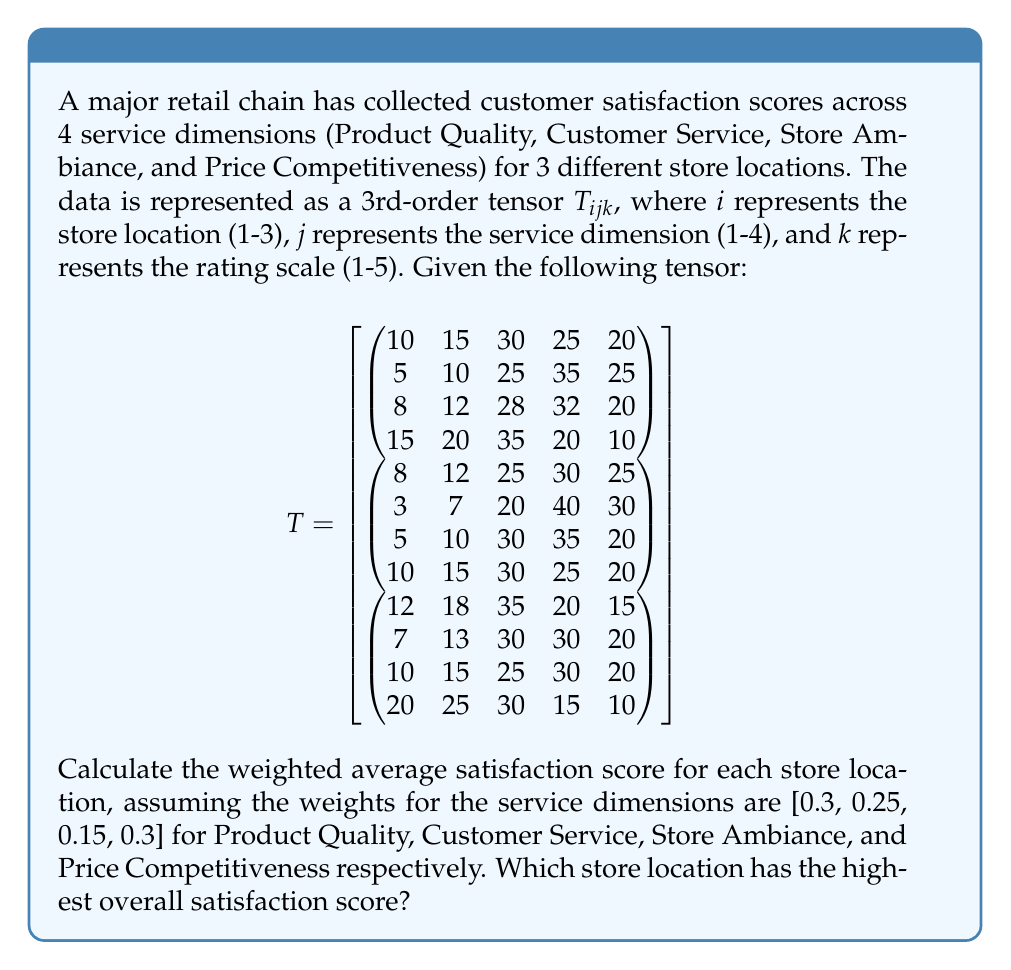Teach me how to tackle this problem. To solve this problem, we'll follow these steps:

1) First, we need to calculate the average satisfaction score for each service dimension in each store. We can do this by multiplying each rating by its corresponding frequency and dividing by the total number of ratings.

2) Then, we'll apply the given weights to these average scores.

3) Finally, we'll sum the weighted scores for each store to get the overall satisfaction score.

Let's go through this process for each store:

Store 1:

Product Quality:
$\frac{1(10) + 2(15) + 3(30) + 4(25) + 5(20)}{10+15+30+25+20} = \frac{325}{100} = 3.25$

Customer Service:
$\frac{1(5) + 2(10) + 3(25) + 4(35) + 5(25)}{5+10+25+35+25} = \frac{365}{100} = 3.65$

Store Ambiance:
$\frac{1(8) + 2(12) + 3(28) + 4(32) + 5(20)}{8+12+28+32+20} = \frac{344}{100} = 3.44$

Price Competitiveness:
$\frac{1(15) + 2(20) + 3(35) + 4(20) + 5(10)}{15+20+35+20+10} = \frac{290}{100} = 2.90$

Weighted Score:
$3.25(0.3) + 3.65(0.25) + 3.44(0.15) + 2.90(0.3) = 3.2885$

Store 2:

Product Quality: $\frac{370}{100} = 3.70$
Customer Service: $\frac{387}{100} = 3.87$
Store Ambiance: $\frac{355}{100} = 3.55$
Price Competitiveness: $\frac{330}{100} = 3.30$

Weighted Score:
$3.70(0.3) + 3.87(0.25) + 3.55(0.15) + 3.30(0.3) = 3.6065$

Store 3:

Product Quality: $\frac{308}{100} = 3.08$
Customer Service: $\frac{343}{100} = 3.43$
Store Ambiance: $\frac{335}{100} = 3.35$
Price Competitiveness: $\frac{270}{100} = 2.70$

Weighted Score:
$3.08(0.3) + 3.43(0.25) + 3.35(0.15) + 2.70(0.3) = 3.1165$

Comparing the weighted scores:
Store 1: 3.2885
Store 2: 3.6065
Store 3: 3.1165

Store 2 has the highest overall satisfaction score.
Answer: Store 2 